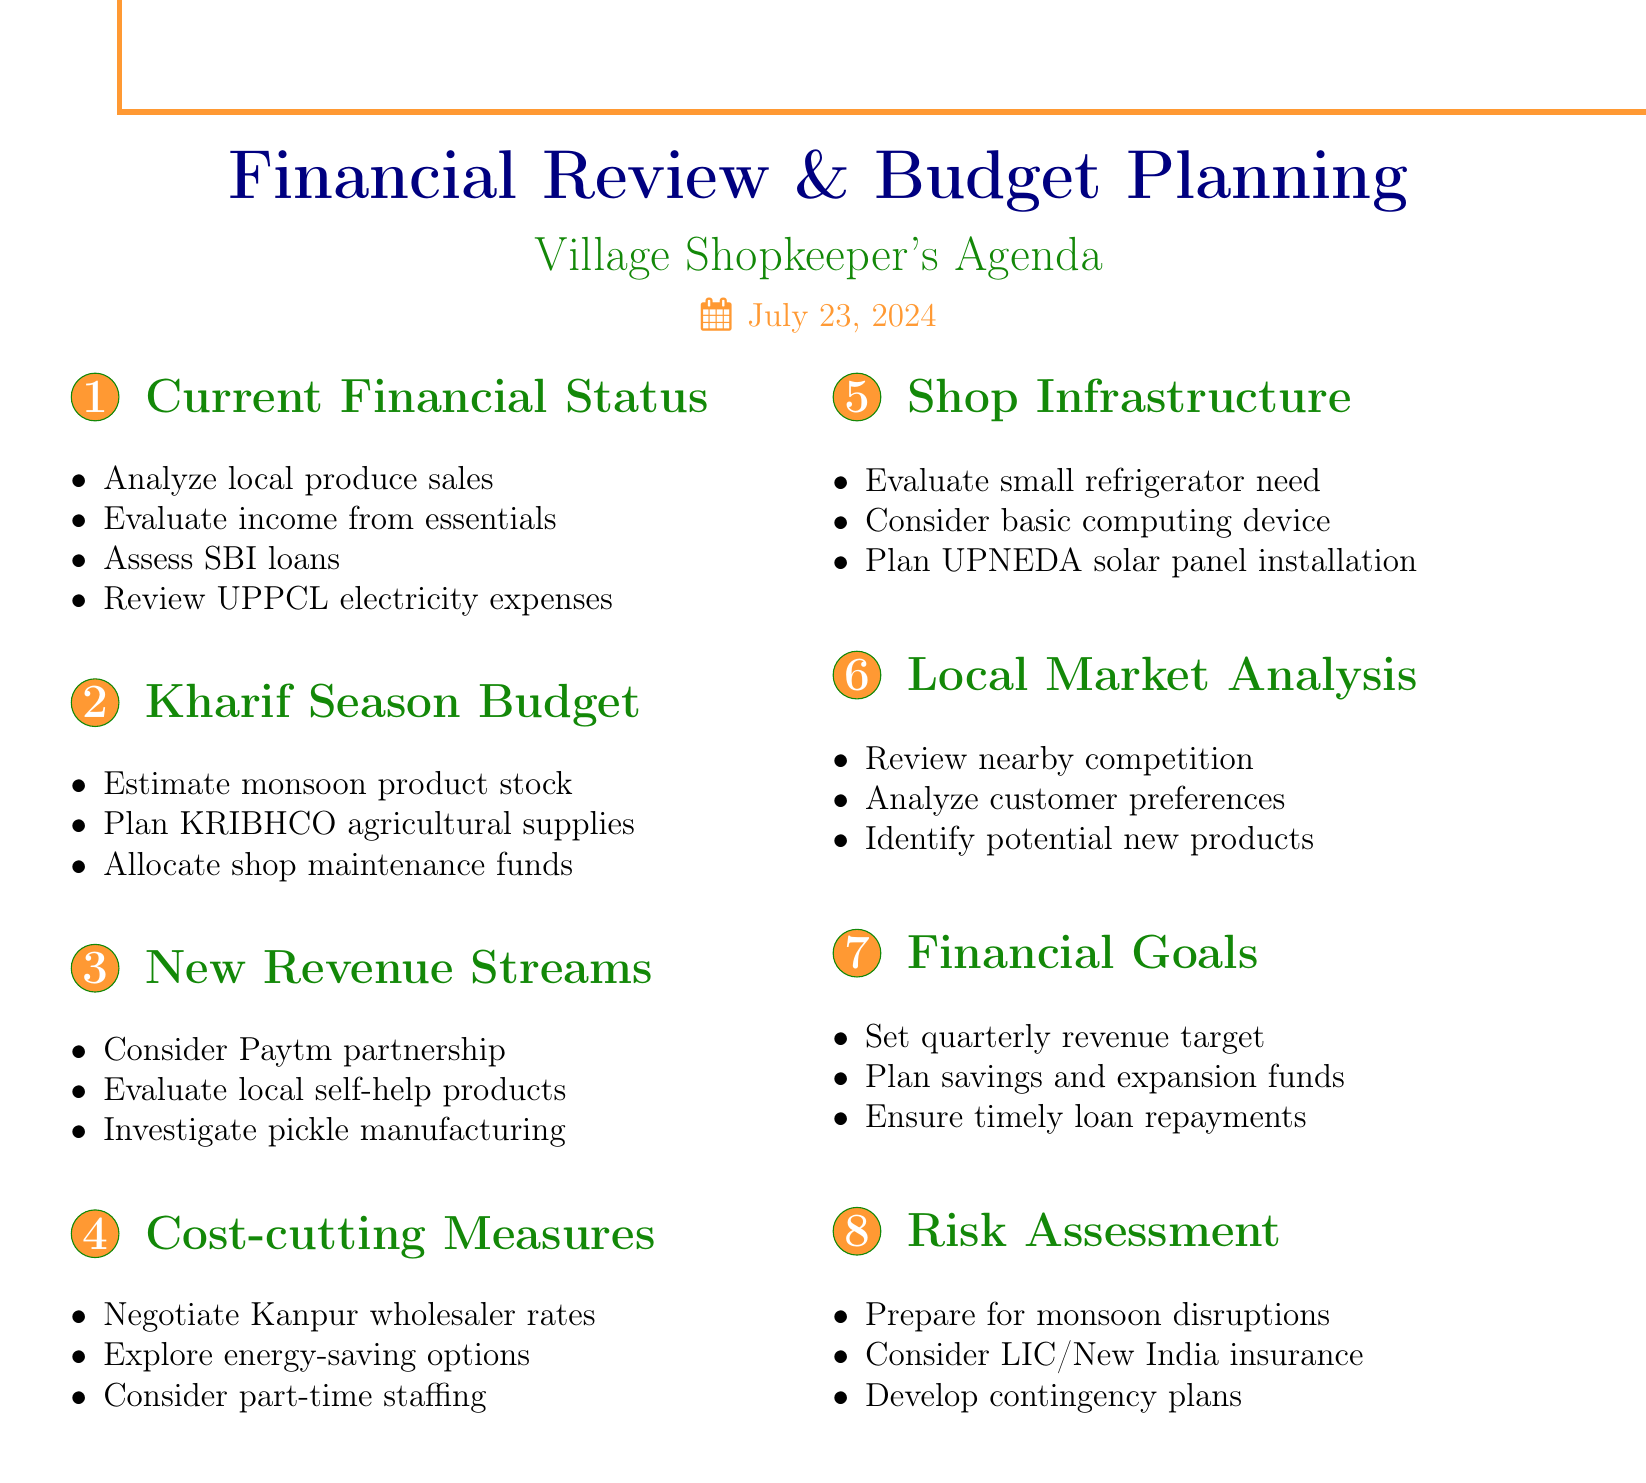What is the first agenda item? The first agenda item listed in the document is "Review of Current Financial Status."
Answer: Review of Current Financial Status How many subtopics are under 'Cost-cutting Measures'? The document lists three subtopics under 'Cost-cutting Measures.'
Answer: 3 What product categories are mentioned for Kharif Season budget planning? The document specifies 'monsoon-related products' and 'agricultural supplies' as product categories.
Answer: Monsoon-related products and agricultural supplies What is a proposed new revenue stream? One of the proposed new revenue streams is a partnership with Paytm for mobile recharge and bill payment services.
Answer: Partnership with Paytm What type of infrastructure investment is planned? The document mentions the evaluation of a small refrigerator for perishable items as an infrastructure investment.
Answer: Small refrigerator What is one of the financial goals for the upcoming quarter? A financial goal mentioned in the document is establishing a target revenue for the upcoming quarter.
Answer: Establishing target revenue Which bank is mentioned in relation to outstanding loans? The document refers to the State Bank of India for outstanding loans.
Answer: State Bank of India What should be prepared for potential supply chain issues? The document suggests preparing for potential supply chain disruptions due to monsoon.
Answer: Supply chain disruptions due to monsoon 